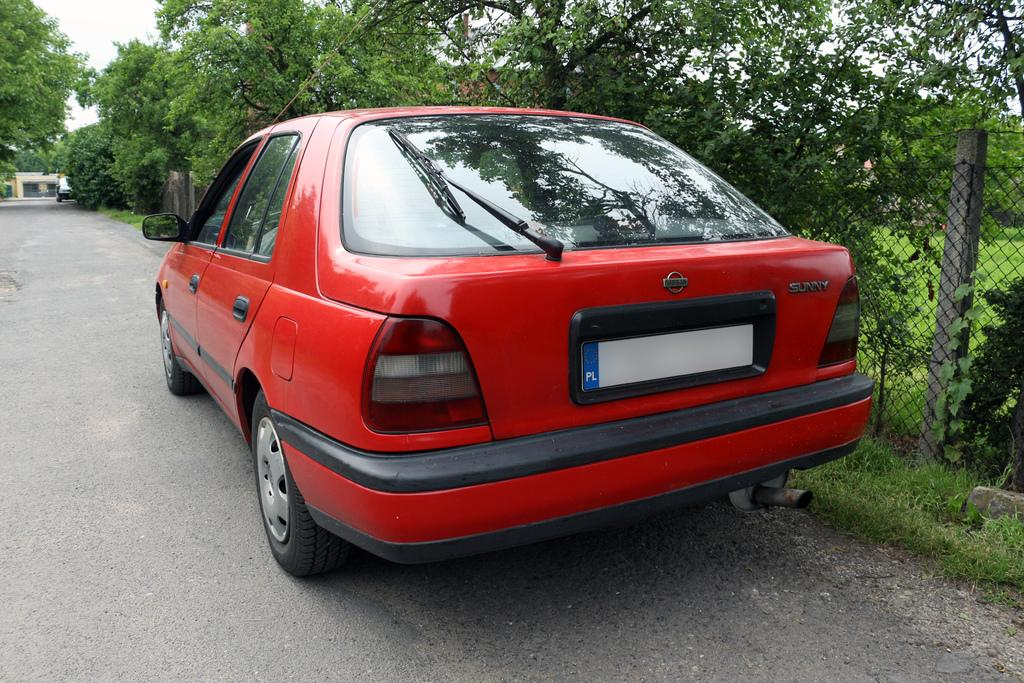What is the main subject of the image? The main subject of the image is a car. Where is the car located in the image? The car is on the road in the image. What can be seen on the right side of the image? There is a mesh on the right side of the image. What is visible in the background of the image? Trees and the sky are visible in the background of the image. How many ladybugs can be seen on the car in the image? There are no ladybugs present on the car in the image. What type of waste is visible on the side of the road in the image? There is no waste visible on the side of the road in the image. 